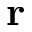Convert formula to latex. <formula><loc_0><loc_0><loc_500><loc_500>r</formula> 